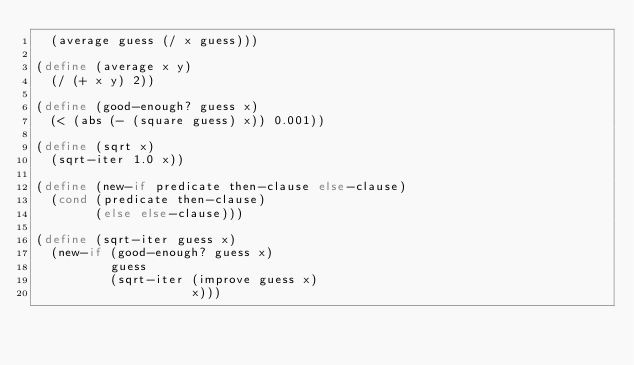Convert code to text. <code><loc_0><loc_0><loc_500><loc_500><_Scheme_>  (average guess (/ x guess)))

(define (average x y)
  (/ (+ x y) 2))

(define (good-enough? guess x)
  (< (abs (- (square guess) x)) 0.001))

(define (sqrt x)
  (sqrt-iter 1.0 x))

(define (new-if predicate then-clause else-clause)
  (cond (predicate then-clause)
        (else else-clause)))

(define (sqrt-iter guess x)
  (new-if (good-enough? guess x)
          guess
          (sqrt-iter (improve guess x)
                     x)))</code> 